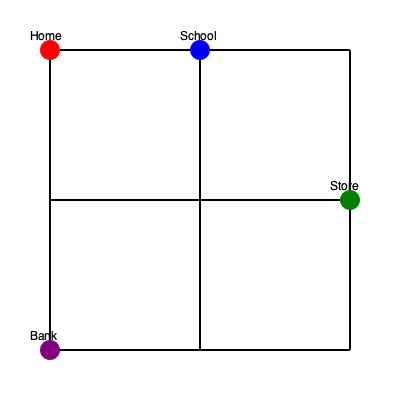As a busy single parent, you need to plan the most efficient route for your errands. Starting from home, you need to drop off your child at school, go to the store for groceries, and then visit the bank before returning home. Each block on the map represents 1 km. What is the minimum total distance (in km) you need to travel to complete all your tasks and return home? Let's break this down step-by-step:

1. Home to School:
   - 1 block east = 1 km

2. School to Store:
   - 1 block east + 1 block south = 2 km

3. Store to Bank:
   - 3 blocks west + 1 block south = 4 km

4. Bank to Home:
   - 3 blocks north = 3 km

To calculate the total distance:
$$\text{Total Distance} = 1 + 2 + 4 + 3 = 10 \text{ km}$$

This route ensures that all tasks are completed with the minimum distance traveled, considering the layout of the city and the locations of each destination.
Answer: 10 km 